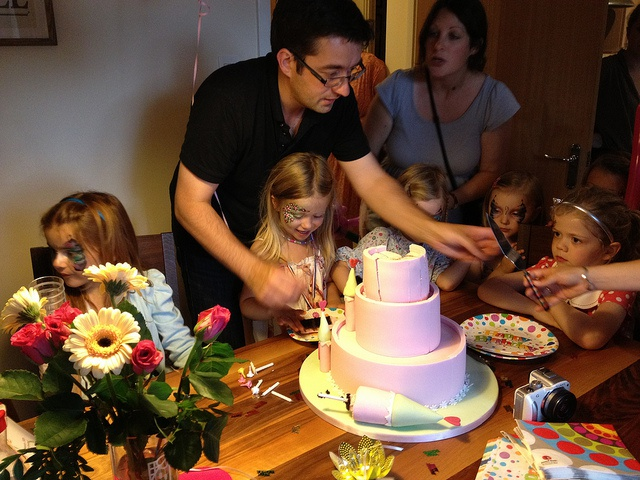Describe the objects in this image and their specific colors. I can see dining table in black, brown, khaki, and lightgray tones, people in black, brown, tan, and maroon tones, potted plant in black, olive, maroon, and brown tones, people in black and maroon tones, and people in black, maroon, and brown tones in this image. 